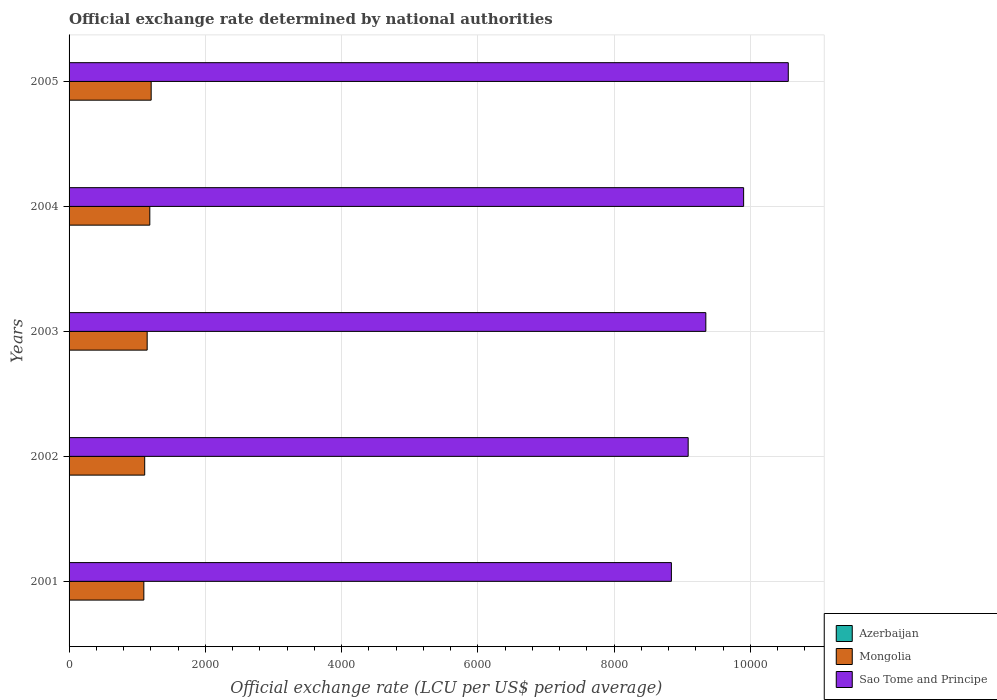Are the number of bars on each tick of the Y-axis equal?
Provide a succinct answer. Yes. What is the official exchange rate in Mongolia in 2005?
Your answer should be very brief. 1205.25. Across all years, what is the maximum official exchange rate in Sao Tome and Principe?
Your answer should be very brief. 1.06e+04. Across all years, what is the minimum official exchange rate in Azerbaijan?
Your response must be concise. 0.93. In which year was the official exchange rate in Azerbaijan maximum?
Your answer should be very brief. 2004. What is the total official exchange rate in Azerbaijan in the graph?
Offer a very short reply. 4.81. What is the difference between the official exchange rate in Sao Tome and Principe in 2001 and that in 2004?
Give a very brief answer. -1060.21. What is the difference between the official exchange rate in Azerbaijan in 2004 and the official exchange rate in Mongolia in 2005?
Make the answer very short. -1204.26. What is the average official exchange rate in Azerbaijan per year?
Offer a very short reply. 0.96. In the year 2003, what is the difference between the official exchange rate in Sao Tome and Principe and official exchange rate in Azerbaijan?
Offer a very short reply. 9346.6. In how many years, is the official exchange rate in Sao Tome and Principe greater than 8400 LCU?
Keep it short and to the point. 5. What is the ratio of the official exchange rate in Azerbaijan in 2003 to that in 2005?
Make the answer very short. 1.04. Is the official exchange rate in Mongolia in 2001 less than that in 2003?
Keep it short and to the point. Yes. What is the difference between the highest and the second highest official exchange rate in Sao Tome and Principe?
Give a very brief answer. 655.65. What is the difference between the highest and the lowest official exchange rate in Azerbaijan?
Your response must be concise. 0.05. Is the sum of the official exchange rate in Azerbaijan in 2004 and 2005 greater than the maximum official exchange rate in Sao Tome and Principe across all years?
Ensure brevity in your answer.  No. What does the 2nd bar from the top in 2001 represents?
Your answer should be very brief. Mongolia. What does the 3rd bar from the bottom in 2001 represents?
Make the answer very short. Sao Tome and Principe. Is it the case that in every year, the sum of the official exchange rate in Mongolia and official exchange rate in Azerbaijan is greater than the official exchange rate in Sao Tome and Principe?
Offer a terse response. No. How many bars are there?
Your answer should be compact. 15. How many years are there in the graph?
Make the answer very short. 5. What is the difference between two consecutive major ticks on the X-axis?
Make the answer very short. 2000. How many legend labels are there?
Keep it short and to the point. 3. How are the legend labels stacked?
Provide a short and direct response. Vertical. What is the title of the graph?
Your answer should be very brief. Official exchange rate determined by national authorities. What is the label or title of the X-axis?
Ensure brevity in your answer.  Official exchange rate (LCU per US$ period average). What is the Official exchange rate (LCU per US$ period average) of Azerbaijan in 2001?
Keep it short and to the point. 0.93. What is the Official exchange rate (LCU per US$ period average) of Mongolia in 2001?
Provide a succinct answer. 1097.7. What is the Official exchange rate (LCU per US$ period average) in Sao Tome and Principe in 2001?
Provide a short and direct response. 8842.11. What is the Official exchange rate (LCU per US$ period average) of Azerbaijan in 2002?
Keep it short and to the point. 0.97. What is the Official exchange rate (LCU per US$ period average) in Mongolia in 2002?
Your answer should be compact. 1110.31. What is the Official exchange rate (LCU per US$ period average) in Sao Tome and Principe in 2002?
Offer a terse response. 9088.33. What is the Official exchange rate (LCU per US$ period average) in Azerbaijan in 2003?
Provide a short and direct response. 0.98. What is the Official exchange rate (LCU per US$ period average) in Mongolia in 2003?
Offer a terse response. 1146.54. What is the Official exchange rate (LCU per US$ period average) in Sao Tome and Principe in 2003?
Provide a succinct answer. 9347.58. What is the Official exchange rate (LCU per US$ period average) of Azerbaijan in 2004?
Your answer should be very brief. 0.98. What is the Official exchange rate (LCU per US$ period average) in Mongolia in 2004?
Your answer should be very brief. 1185.3. What is the Official exchange rate (LCU per US$ period average) in Sao Tome and Principe in 2004?
Your answer should be very brief. 9902.32. What is the Official exchange rate (LCU per US$ period average) of Azerbaijan in 2005?
Offer a terse response. 0.95. What is the Official exchange rate (LCU per US$ period average) in Mongolia in 2005?
Provide a succinct answer. 1205.25. What is the Official exchange rate (LCU per US$ period average) of Sao Tome and Principe in 2005?
Make the answer very short. 1.06e+04. Across all years, what is the maximum Official exchange rate (LCU per US$ period average) in Azerbaijan?
Make the answer very short. 0.98. Across all years, what is the maximum Official exchange rate (LCU per US$ period average) in Mongolia?
Provide a short and direct response. 1205.25. Across all years, what is the maximum Official exchange rate (LCU per US$ period average) of Sao Tome and Principe?
Your response must be concise. 1.06e+04. Across all years, what is the minimum Official exchange rate (LCU per US$ period average) in Azerbaijan?
Your answer should be compact. 0.93. Across all years, what is the minimum Official exchange rate (LCU per US$ period average) in Mongolia?
Provide a short and direct response. 1097.7. Across all years, what is the minimum Official exchange rate (LCU per US$ period average) of Sao Tome and Principe?
Provide a succinct answer. 8842.11. What is the total Official exchange rate (LCU per US$ period average) in Azerbaijan in the graph?
Make the answer very short. 4.81. What is the total Official exchange rate (LCU per US$ period average) in Mongolia in the graph?
Offer a terse response. 5745.09. What is the total Official exchange rate (LCU per US$ period average) of Sao Tome and Principe in the graph?
Keep it short and to the point. 4.77e+04. What is the difference between the Official exchange rate (LCU per US$ period average) in Azerbaijan in 2001 and that in 2002?
Offer a terse response. -0.04. What is the difference between the Official exchange rate (LCU per US$ period average) of Mongolia in 2001 and that in 2002?
Keep it short and to the point. -12.61. What is the difference between the Official exchange rate (LCU per US$ period average) in Sao Tome and Principe in 2001 and that in 2002?
Provide a succinct answer. -246.22. What is the difference between the Official exchange rate (LCU per US$ period average) of Azerbaijan in 2001 and that in 2003?
Offer a very short reply. -0.05. What is the difference between the Official exchange rate (LCU per US$ period average) in Mongolia in 2001 and that in 2003?
Keep it short and to the point. -48.84. What is the difference between the Official exchange rate (LCU per US$ period average) of Sao Tome and Principe in 2001 and that in 2003?
Ensure brevity in your answer.  -505.47. What is the difference between the Official exchange rate (LCU per US$ period average) of Azerbaijan in 2001 and that in 2004?
Ensure brevity in your answer.  -0.05. What is the difference between the Official exchange rate (LCU per US$ period average) of Mongolia in 2001 and that in 2004?
Make the answer very short. -87.6. What is the difference between the Official exchange rate (LCU per US$ period average) of Sao Tome and Principe in 2001 and that in 2004?
Make the answer very short. -1060.21. What is the difference between the Official exchange rate (LCU per US$ period average) of Azerbaijan in 2001 and that in 2005?
Offer a very short reply. -0.01. What is the difference between the Official exchange rate (LCU per US$ period average) of Mongolia in 2001 and that in 2005?
Offer a terse response. -107.55. What is the difference between the Official exchange rate (LCU per US$ period average) of Sao Tome and Principe in 2001 and that in 2005?
Provide a succinct answer. -1715.86. What is the difference between the Official exchange rate (LCU per US$ period average) of Azerbaijan in 2002 and that in 2003?
Keep it short and to the point. -0.01. What is the difference between the Official exchange rate (LCU per US$ period average) of Mongolia in 2002 and that in 2003?
Your answer should be very brief. -36.23. What is the difference between the Official exchange rate (LCU per US$ period average) of Sao Tome and Principe in 2002 and that in 2003?
Your answer should be compact. -259.26. What is the difference between the Official exchange rate (LCU per US$ period average) in Azerbaijan in 2002 and that in 2004?
Your response must be concise. -0.01. What is the difference between the Official exchange rate (LCU per US$ period average) in Mongolia in 2002 and that in 2004?
Make the answer very short. -74.99. What is the difference between the Official exchange rate (LCU per US$ period average) in Sao Tome and Principe in 2002 and that in 2004?
Offer a terse response. -814. What is the difference between the Official exchange rate (LCU per US$ period average) in Azerbaijan in 2002 and that in 2005?
Provide a short and direct response. 0.03. What is the difference between the Official exchange rate (LCU per US$ period average) in Mongolia in 2002 and that in 2005?
Give a very brief answer. -94.94. What is the difference between the Official exchange rate (LCU per US$ period average) of Sao Tome and Principe in 2002 and that in 2005?
Your response must be concise. -1469.65. What is the difference between the Official exchange rate (LCU per US$ period average) of Azerbaijan in 2003 and that in 2004?
Offer a terse response. -0. What is the difference between the Official exchange rate (LCU per US$ period average) of Mongolia in 2003 and that in 2004?
Keep it short and to the point. -38.76. What is the difference between the Official exchange rate (LCU per US$ period average) in Sao Tome and Principe in 2003 and that in 2004?
Your response must be concise. -554.74. What is the difference between the Official exchange rate (LCU per US$ period average) in Azerbaijan in 2003 and that in 2005?
Offer a terse response. 0.04. What is the difference between the Official exchange rate (LCU per US$ period average) of Mongolia in 2003 and that in 2005?
Provide a short and direct response. -58.7. What is the difference between the Official exchange rate (LCU per US$ period average) of Sao Tome and Principe in 2003 and that in 2005?
Keep it short and to the point. -1210.39. What is the difference between the Official exchange rate (LCU per US$ period average) in Azerbaijan in 2004 and that in 2005?
Your answer should be very brief. 0.04. What is the difference between the Official exchange rate (LCU per US$ period average) of Mongolia in 2004 and that in 2005?
Your response must be concise. -19.95. What is the difference between the Official exchange rate (LCU per US$ period average) of Sao Tome and Principe in 2004 and that in 2005?
Your response must be concise. -655.65. What is the difference between the Official exchange rate (LCU per US$ period average) in Azerbaijan in 2001 and the Official exchange rate (LCU per US$ period average) in Mongolia in 2002?
Make the answer very short. -1109.38. What is the difference between the Official exchange rate (LCU per US$ period average) of Azerbaijan in 2001 and the Official exchange rate (LCU per US$ period average) of Sao Tome and Principe in 2002?
Your answer should be very brief. -9087.39. What is the difference between the Official exchange rate (LCU per US$ period average) of Mongolia in 2001 and the Official exchange rate (LCU per US$ period average) of Sao Tome and Principe in 2002?
Give a very brief answer. -7990.63. What is the difference between the Official exchange rate (LCU per US$ period average) in Azerbaijan in 2001 and the Official exchange rate (LCU per US$ period average) in Mongolia in 2003?
Provide a succinct answer. -1145.61. What is the difference between the Official exchange rate (LCU per US$ period average) in Azerbaijan in 2001 and the Official exchange rate (LCU per US$ period average) in Sao Tome and Principe in 2003?
Provide a succinct answer. -9346.65. What is the difference between the Official exchange rate (LCU per US$ period average) of Mongolia in 2001 and the Official exchange rate (LCU per US$ period average) of Sao Tome and Principe in 2003?
Give a very brief answer. -8249.89. What is the difference between the Official exchange rate (LCU per US$ period average) in Azerbaijan in 2001 and the Official exchange rate (LCU per US$ period average) in Mongolia in 2004?
Make the answer very short. -1184.37. What is the difference between the Official exchange rate (LCU per US$ period average) of Azerbaijan in 2001 and the Official exchange rate (LCU per US$ period average) of Sao Tome and Principe in 2004?
Provide a succinct answer. -9901.39. What is the difference between the Official exchange rate (LCU per US$ period average) of Mongolia in 2001 and the Official exchange rate (LCU per US$ period average) of Sao Tome and Principe in 2004?
Make the answer very short. -8804.63. What is the difference between the Official exchange rate (LCU per US$ period average) in Azerbaijan in 2001 and the Official exchange rate (LCU per US$ period average) in Mongolia in 2005?
Provide a short and direct response. -1204.32. What is the difference between the Official exchange rate (LCU per US$ period average) of Azerbaijan in 2001 and the Official exchange rate (LCU per US$ period average) of Sao Tome and Principe in 2005?
Your response must be concise. -1.06e+04. What is the difference between the Official exchange rate (LCU per US$ period average) in Mongolia in 2001 and the Official exchange rate (LCU per US$ period average) in Sao Tome and Principe in 2005?
Offer a very short reply. -9460.27. What is the difference between the Official exchange rate (LCU per US$ period average) of Azerbaijan in 2002 and the Official exchange rate (LCU per US$ period average) of Mongolia in 2003?
Provide a short and direct response. -1145.57. What is the difference between the Official exchange rate (LCU per US$ period average) of Azerbaijan in 2002 and the Official exchange rate (LCU per US$ period average) of Sao Tome and Principe in 2003?
Offer a very short reply. -9346.61. What is the difference between the Official exchange rate (LCU per US$ period average) of Mongolia in 2002 and the Official exchange rate (LCU per US$ period average) of Sao Tome and Principe in 2003?
Provide a succinct answer. -8237.27. What is the difference between the Official exchange rate (LCU per US$ period average) of Azerbaijan in 2002 and the Official exchange rate (LCU per US$ period average) of Mongolia in 2004?
Offer a terse response. -1184.33. What is the difference between the Official exchange rate (LCU per US$ period average) of Azerbaijan in 2002 and the Official exchange rate (LCU per US$ period average) of Sao Tome and Principe in 2004?
Provide a short and direct response. -9901.35. What is the difference between the Official exchange rate (LCU per US$ period average) of Mongolia in 2002 and the Official exchange rate (LCU per US$ period average) of Sao Tome and Principe in 2004?
Your answer should be compact. -8792.01. What is the difference between the Official exchange rate (LCU per US$ period average) in Azerbaijan in 2002 and the Official exchange rate (LCU per US$ period average) in Mongolia in 2005?
Provide a short and direct response. -1204.27. What is the difference between the Official exchange rate (LCU per US$ period average) of Azerbaijan in 2002 and the Official exchange rate (LCU per US$ period average) of Sao Tome and Principe in 2005?
Make the answer very short. -1.06e+04. What is the difference between the Official exchange rate (LCU per US$ period average) of Mongolia in 2002 and the Official exchange rate (LCU per US$ period average) of Sao Tome and Principe in 2005?
Offer a very short reply. -9447.66. What is the difference between the Official exchange rate (LCU per US$ period average) of Azerbaijan in 2003 and the Official exchange rate (LCU per US$ period average) of Mongolia in 2004?
Your answer should be compact. -1184.32. What is the difference between the Official exchange rate (LCU per US$ period average) of Azerbaijan in 2003 and the Official exchange rate (LCU per US$ period average) of Sao Tome and Principe in 2004?
Your answer should be very brief. -9901.34. What is the difference between the Official exchange rate (LCU per US$ period average) of Mongolia in 2003 and the Official exchange rate (LCU per US$ period average) of Sao Tome and Principe in 2004?
Provide a succinct answer. -8755.78. What is the difference between the Official exchange rate (LCU per US$ period average) in Azerbaijan in 2003 and the Official exchange rate (LCU per US$ period average) in Mongolia in 2005?
Provide a short and direct response. -1204.26. What is the difference between the Official exchange rate (LCU per US$ period average) of Azerbaijan in 2003 and the Official exchange rate (LCU per US$ period average) of Sao Tome and Principe in 2005?
Your response must be concise. -1.06e+04. What is the difference between the Official exchange rate (LCU per US$ period average) in Mongolia in 2003 and the Official exchange rate (LCU per US$ period average) in Sao Tome and Principe in 2005?
Give a very brief answer. -9411.43. What is the difference between the Official exchange rate (LCU per US$ period average) in Azerbaijan in 2004 and the Official exchange rate (LCU per US$ period average) in Mongolia in 2005?
Provide a succinct answer. -1204.26. What is the difference between the Official exchange rate (LCU per US$ period average) in Azerbaijan in 2004 and the Official exchange rate (LCU per US$ period average) in Sao Tome and Principe in 2005?
Ensure brevity in your answer.  -1.06e+04. What is the difference between the Official exchange rate (LCU per US$ period average) of Mongolia in 2004 and the Official exchange rate (LCU per US$ period average) of Sao Tome and Principe in 2005?
Your response must be concise. -9372.67. What is the average Official exchange rate (LCU per US$ period average) of Azerbaijan per year?
Ensure brevity in your answer.  0.96. What is the average Official exchange rate (LCU per US$ period average) of Mongolia per year?
Your answer should be very brief. 1149.02. What is the average Official exchange rate (LCU per US$ period average) in Sao Tome and Principe per year?
Make the answer very short. 9547.66. In the year 2001, what is the difference between the Official exchange rate (LCU per US$ period average) in Azerbaijan and Official exchange rate (LCU per US$ period average) in Mongolia?
Give a very brief answer. -1096.77. In the year 2001, what is the difference between the Official exchange rate (LCU per US$ period average) of Azerbaijan and Official exchange rate (LCU per US$ period average) of Sao Tome and Principe?
Your answer should be very brief. -8841.18. In the year 2001, what is the difference between the Official exchange rate (LCU per US$ period average) in Mongolia and Official exchange rate (LCU per US$ period average) in Sao Tome and Principe?
Your response must be concise. -7744.41. In the year 2002, what is the difference between the Official exchange rate (LCU per US$ period average) of Azerbaijan and Official exchange rate (LCU per US$ period average) of Mongolia?
Your answer should be compact. -1109.34. In the year 2002, what is the difference between the Official exchange rate (LCU per US$ period average) in Azerbaijan and Official exchange rate (LCU per US$ period average) in Sao Tome and Principe?
Your answer should be compact. -9087.35. In the year 2002, what is the difference between the Official exchange rate (LCU per US$ period average) in Mongolia and Official exchange rate (LCU per US$ period average) in Sao Tome and Principe?
Your response must be concise. -7978.02. In the year 2003, what is the difference between the Official exchange rate (LCU per US$ period average) of Azerbaijan and Official exchange rate (LCU per US$ period average) of Mongolia?
Offer a very short reply. -1145.56. In the year 2003, what is the difference between the Official exchange rate (LCU per US$ period average) of Azerbaijan and Official exchange rate (LCU per US$ period average) of Sao Tome and Principe?
Make the answer very short. -9346.6. In the year 2003, what is the difference between the Official exchange rate (LCU per US$ period average) of Mongolia and Official exchange rate (LCU per US$ period average) of Sao Tome and Principe?
Your response must be concise. -8201.04. In the year 2004, what is the difference between the Official exchange rate (LCU per US$ period average) of Azerbaijan and Official exchange rate (LCU per US$ period average) of Mongolia?
Give a very brief answer. -1184.31. In the year 2004, what is the difference between the Official exchange rate (LCU per US$ period average) of Azerbaijan and Official exchange rate (LCU per US$ period average) of Sao Tome and Principe?
Provide a succinct answer. -9901.34. In the year 2004, what is the difference between the Official exchange rate (LCU per US$ period average) of Mongolia and Official exchange rate (LCU per US$ period average) of Sao Tome and Principe?
Offer a very short reply. -8717.03. In the year 2005, what is the difference between the Official exchange rate (LCU per US$ period average) of Azerbaijan and Official exchange rate (LCU per US$ period average) of Mongolia?
Provide a succinct answer. -1204.3. In the year 2005, what is the difference between the Official exchange rate (LCU per US$ period average) in Azerbaijan and Official exchange rate (LCU per US$ period average) in Sao Tome and Principe?
Your answer should be compact. -1.06e+04. In the year 2005, what is the difference between the Official exchange rate (LCU per US$ period average) in Mongolia and Official exchange rate (LCU per US$ period average) in Sao Tome and Principe?
Offer a very short reply. -9352.72. What is the ratio of the Official exchange rate (LCU per US$ period average) of Azerbaijan in 2001 to that in 2002?
Your answer should be very brief. 0.96. What is the ratio of the Official exchange rate (LCU per US$ period average) in Sao Tome and Principe in 2001 to that in 2002?
Provide a short and direct response. 0.97. What is the ratio of the Official exchange rate (LCU per US$ period average) of Azerbaijan in 2001 to that in 2003?
Provide a succinct answer. 0.95. What is the ratio of the Official exchange rate (LCU per US$ period average) in Mongolia in 2001 to that in 2003?
Keep it short and to the point. 0.96. What is the ratio of the Official exchange rate (LCU per US$ period average) in Sao Tome and Principe in 2001 to that in 2003?
Ensure brevity in your answer.  0.95. What is the ratio of the Official exchange rate (LCU per US$ period average) of Azerbaijan in 2001 to that in 2004?
Make the answer very short. 0.95. What is the ratio of the Official exchange rate (LCU per US$ period average) of Mongolia in 2001 to that in 2004?
Your answer should be very brief. 0.93. What is the ratio of the Official exchange rate (LCU per US$ period average) of Sao Tome and Principe in 2001 to that in 2004?
Keep it short and to the point. 0.89. What is the ratio of the Official exchange rate (LCU per US$ period average) of Azerbaijan in 2001 to that in 2005?
Make the answer very short. 0.99. What is the ratio of the Official exchange rate (LCU per US$ period average) in Mongolia in 2001 to that in 2005?
Give a very brief answer. 0.91. What is the ratio of the Official exchange rate (LCU per US$ period average) in Sao Tome and Principe in 2001 to that in 2005?
Offer a very short reply. 0.84. What is the ratio of the Official exchange rate (LCU per US$ period average) in Mongolia in 2002 to that in 2003?
Your answer should be compact. 0.97. What is the ratio of the Official exchange rate (LCU per US$ period average) in Sao Tome and Principe in 2002 to that in 2003?
Ensure brevity in your answer.  0.97. What is the ratio of the Official exchange rate (LCU per US$ period average) in Azerbaijan in 2002 to that in 2004?
Provide a succinct answer. 0.99. What is the ratio of the Official exchange rate (LCU per US$ period average) of Mongolia in 2002 to that in 2004?
Provide a succinct answer. 0.94. What is the ratio of the Official exchange rate (LCU per US$ period average) in Sao Tome and Principe in 2002 to that in 2004?
Make the answer very short. 0.92. What is the ratio of the Official exchange rate (LCU per US$ period average) in Azerbaijan in 2002 to that in 2005?
Your answer should be compact. 1.03. What is the ratio of the Official exchange rate (LCU per US$ period average) of Mongolia in 2002 to that in 2005?
Your answer should be compact. 0.92. What is the ratio of the Official exchange rate (LCU per US$ period average) in Sao Tome and Principe in 2002 to that in 2005?
Provide a short and direct response. 0.86. What is the ratio of the Official exchange rate (LCU per US$ period average) in Mongolia in 2003 to that in 2004?
Your answer should be very brief. 0.97. What is the ratio of the Official exchange rate (LCU per US$ period average) in Sao Tome and Principe in 2003 to that in 2004?
Make the answer very short. 0.94. What is the ratio of the Official exchange rate (LCU per US$ period average) of Azerbaijan in 2003 to that in 2005?
Ensure brevity in your answer.  1.04. What is the ratio of the Official exchange rate (LCU per US$ period average) of Mongolia in 2003 to that in 2005?
Your response must be concise. 0.95. What is the ratio of the Official exchange rate (LCU per US$ period average) in Sao Tome and Principe in 2003 to that in 2005?
Provide a short and direct response. 0.89. What is the ratio of the Official exchange rate (LCU per US$ period average) of Azerbaijan in 2004 to that in 2005?
Your answer should be very brief. 1.04. What is the ratio of the Official exchange rate (LCU per US$ period average) of Mongolia in 2004 to that in 2005?
Offer a very short reply. 0.98. What is the ratio of the Official exchange rate (LCU per US$ period average) in Sao Tome and Principe in 2004 to that in 2005?
Provide a succinct answer. 0.94. What is the difference between the highest and the second highest Official exchange rate (LCU per US$ period average) of Azerbaijan?
Keep it short and to the point. 0. What is the difference between the highest and the second highest Official exchange rate (LCU per US$ period average) in Mongolia?
Your answer should be compact. 19.95. What is the difference between the highest and the second highest Official exchange rate (LCU per US$ period average) in Sao Tome and Principe?
Offer a terse response. 655.65. What is the difference between the highest and the lowest Official exchange rate (LCU per US$ period average) in Azerbaijan?
Your answer should be very brief. 0.05. What is the difference between the highest and the lowest Official exchange rate (LCU per US$ period average) in Mongolia?
Keep it short and to the point. 107.55. What is the difference between the highest and the lowest Official exchange rate (LCU per US$ period average) of Sao Tome and Principe?
Give a very brief answer. 1715.86. 